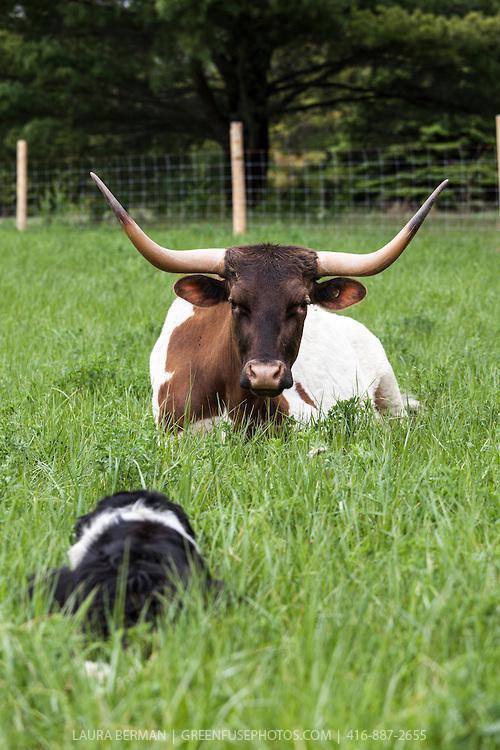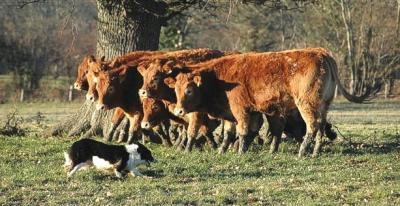The first image is the image on the left, the second image is the image on the right. Evaluate the accuracy of this statement regarding the images: "At least one image features only a black and white dog, with no livestock.". Is it true? Answer yes or no. No. The first image is the image on the left, the second image is the image on the right. Given the left and right images, does the statement "The right image shows only one animal." hold true? Answer yes or no. No. 